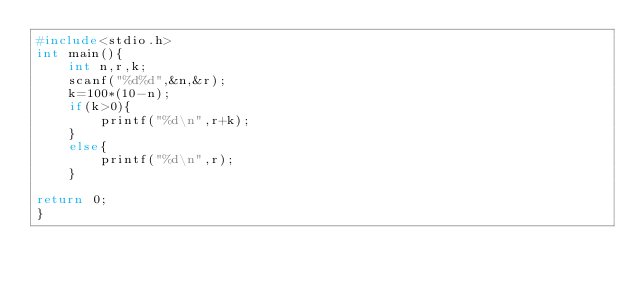<code> <loc_0><loc_0><loc_500><loc_500><_C_>#include<stdio.h>
int main(){
    int n,r,k;
    scanf("%d%d",&n,&r);
    k=100*(10-n);
    if(k>0){
        printf("%d\n",r+k);
    }
    else{
        printf("%d\n",r);
    }

return 0;
}
</code> 